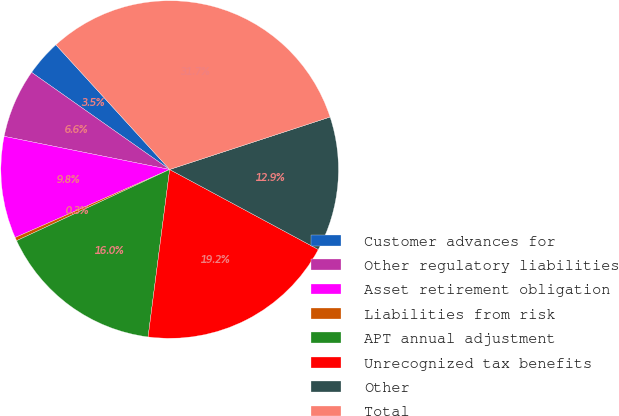<chart> <loc_0><loc_0><loc_500><loc_500><pie_chart><fcel>Customer advances for<fcel>Other regulatory liabilities<fcel>Asset retirement obligation<fcel>Liabilities from risk<fcel>APT annual adjustment<fcel>Unrecognized tax benefits<fcel>Other<fcel>Total<nl><fcel>3.47%<fcel>6.61%<fcel>9.75%<fcel>0.33%<fcel>16.03%<fcel>19.18%<fcel>12.89%<fcel>31.74%<nl></chart> 